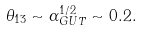Convert formula to latex. <formula><loc_0><loc_0><loc_500><loc_500>\theta _ { 1 3 } \sim \alpha _ { G U T } ^ { 1 / 2 } \sim 0 . 2 .</formula> 